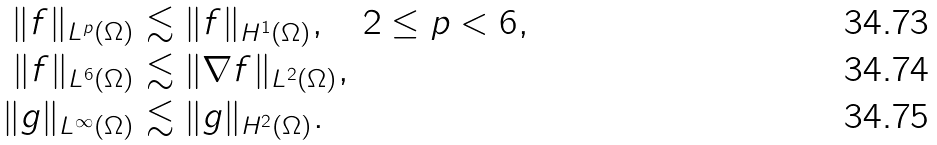Convert formula to latex. <formula><loc_0><loc_0><loc_500><loc_500>\| f \| _ { L ^ { p } ( \Omega ) } & \lesssim \| f \| _ { H ^ { 1 } ( \Omega ) } , \quad 2 \leq p < 6 , \\ \| f \| _ { L ^ { 6 } ( \Omega ) } & \lesssim \| \nabla f \| _ { L ^ { 2 } ( \Omega ) } , \\ \| g \| _ { L ^ { \infty } ( \Omega ) } & \lesssim \| g \| _ { H ^ { 2 } ( \Omega ) } .</formula> 